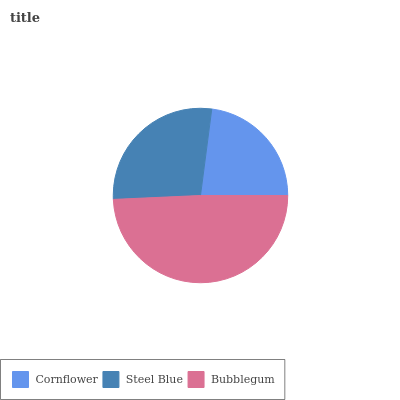Is Cornflower the minimum?
Answer yes or no. Yes. Is Bubblegum the maximum?
Answer yes or no. Yes. Is Steel Blue the minimum?
Answer yes or no. No. Is Steel Blue the maximum?
Answer yes or no. No. Is Steel Blue greater than Cornflower?
Answer yes or no. Yes. Is Cornflower less than Steel Blue?
Answer yes or no. Yes. Is Cornflower greater than Steel Blue?
Answer yes or no. No. Is Steel Blue less than Cornflower?
Answer yes or no. No. Is Steel Blue the high median?
Answer yes or no. Yes. Is Steel Blue the low median?
Answer yes or no. Yes. Is Cornflower the high median?
Answer yes or no. No. Is Cornflower the low median?
Answer yes or no. No. 